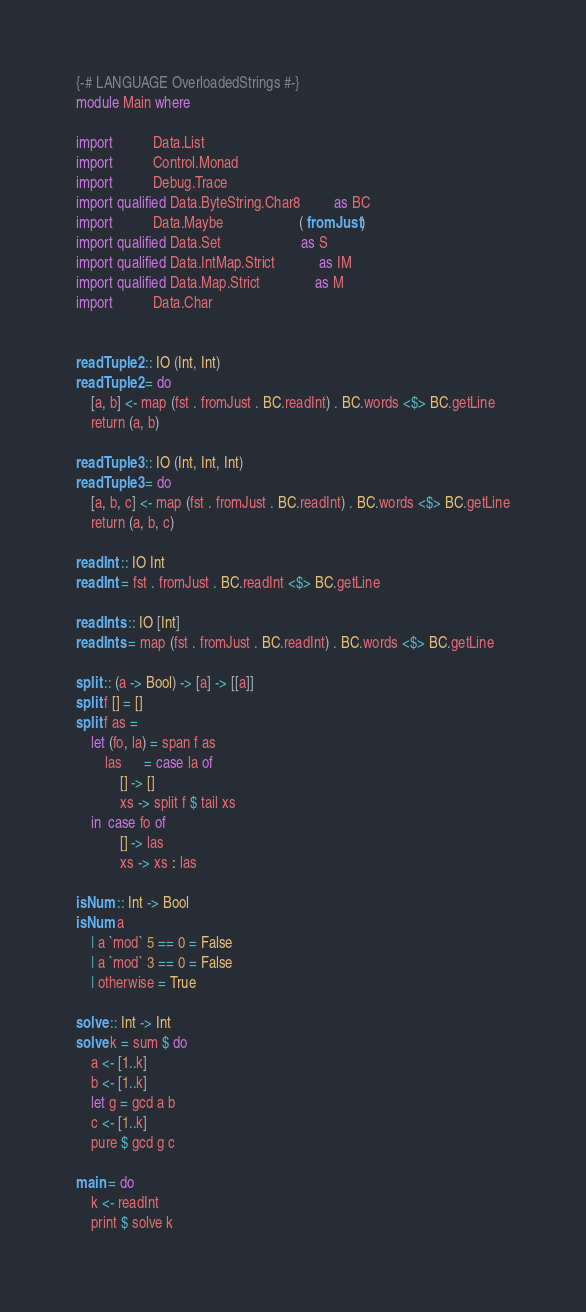Convert code to text. <code><loc_0><loc_0><loc_500><loc_500><_Haskell_>{-# LANGUAGE OverloadedStrings #-}
module Main where

import           Data.List
import           Control.Monad
import           Debug.Trace
import qualified Data.ByteString.Char8         as BC
import           Data.Maybe                     ( fromJust )
import qualified Data.Set                      as S
import qualified Data.IntMap.Strict            as IM
import qualified Data.Map.Strict               as M
import           Data.Char


readTuple2 :: IO (Int, Int)
readTuple2 = do
    [a, b] <- map (fst . fromJust . BC.readInt) . BC.words <$> BC.getLine
    return (a, b)

readTuple3 :: IO (Int, Int, Int)
readTuple3 = do
    [a, b, c] <- map (fst . fromJust . BC.readInt) . BC.words <$> BC.getLine
    return (a, b, c)

readInt :: IO Int
readInt = fst . fromJust . BC.readInt <$> BC.getLine

readInts :: IO [Int]
readInts = map (fst . fromJust . BC.readInt) . BC.words <$> BC.getLine

split :: (a -> Bool) -> [a] -> [[a]]
split f [] = []
split f as =
    let (fo, la) = span f as
        las      = case la of
            [] -> []
            xs -> split f $ tail xs
    in  case fo of
            [] -> las
            xs -> xs : las

isNum :: Int -> Bool
isNum a 
    | a `mod` 5 == 0 = False
    | a `mod` 3 == 0 = False
    | otherwise = True

solve :: Int -> Int
solve k = sum $ do
    a <- [1..k]
    b <- [1..k]
    let g = gcd a b
    c <- [1..k]
    pure $ gcd g c

main = do
    k <- readInt
    print $ solve k



</code> 